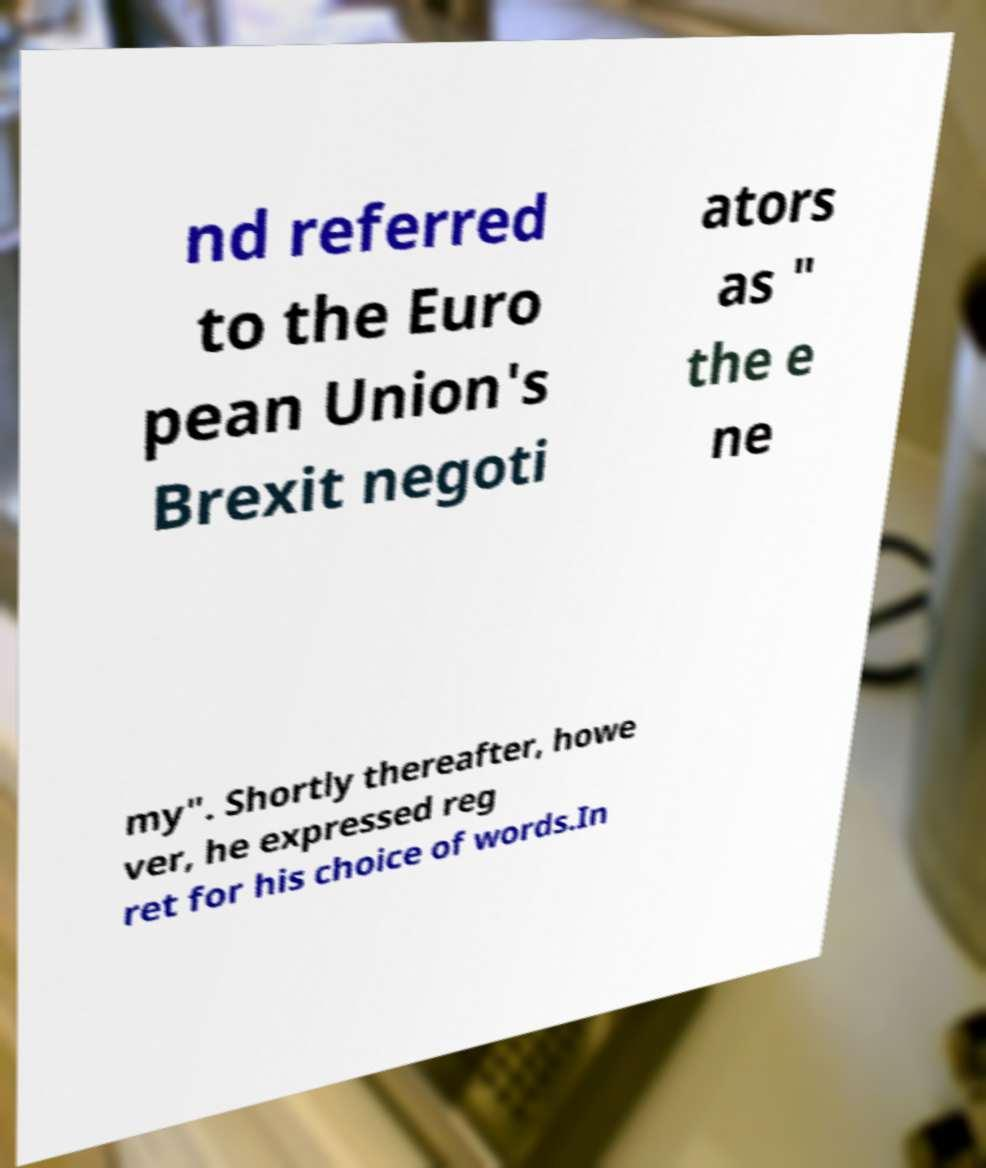Please identify and transcribe the text found in this image. nd referred to the Euro pean Union's Brexit negoti ators as " the e ne my". Shortly thereafter, howe ver, he expressed reg ret for his choice of words.In 